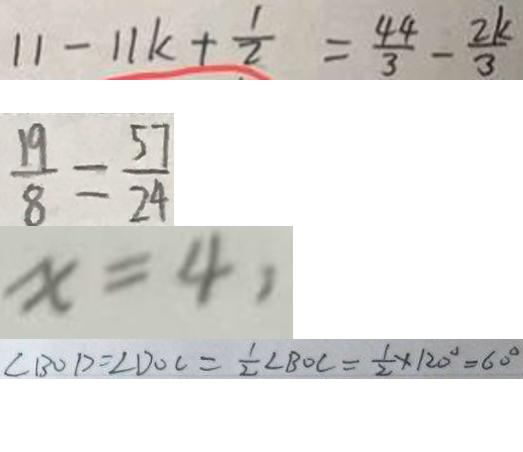<formula> <loc_0><loc_0><loc_500><loc_500>1 1 - 1 1 k + \frac { 1 } { 2 } = \frac { 4 4 } { 3 } - \frac { 2 k } { 3 } 
 \frac { 1 9 } { 8 } = \frac { 5 7 } { 2 4 } 
 x = 4 , 
 \angle B O D = \angle D O C = \frac { 1 } { 2 } \angle B O C = \frac { 1 } { 2 } \times 1 2 0 ^ { \circ } = 6 0 ^ { \circ }</formula> 